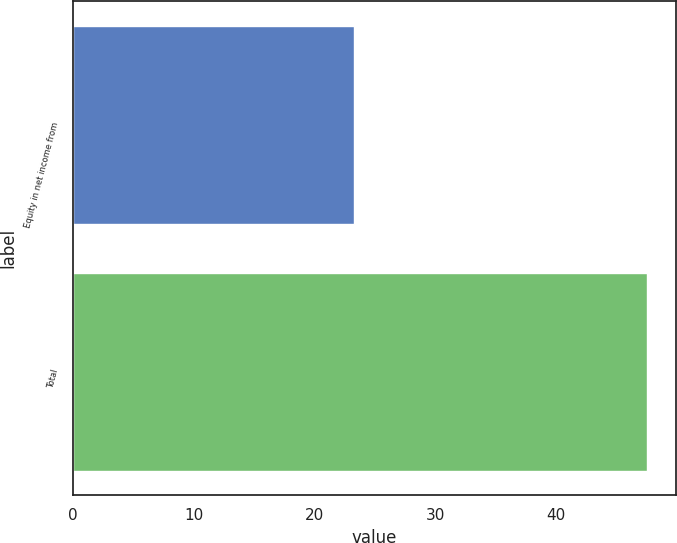Convert chart to OTSL. <chart><loc_0><loc_0><loc_500><loc_500><bar_chart><fcel>Equity in net income from<fcel>Total<nl><fcel>23.3<fcel>47.6<nl></chart> 